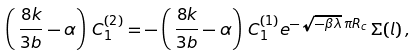Convert formula to latex. <formula><loc_0><loc_0><loc_500><loc_500>\left ( \, \frac { 8 k } { 3 b } - \alpha \right ) \, C ^ { ( 2 ) } _ { 1 } = - \left ( \, \frac { 8 k } { 3 b } - \alpha \right ) \, C ^ { ( 1 ) } _ { 1 } e ^ { - \sqrt { - \beta \lambda } \, \pi R _ { c } } \, \Sigma ( l ) \, ,</formula> 